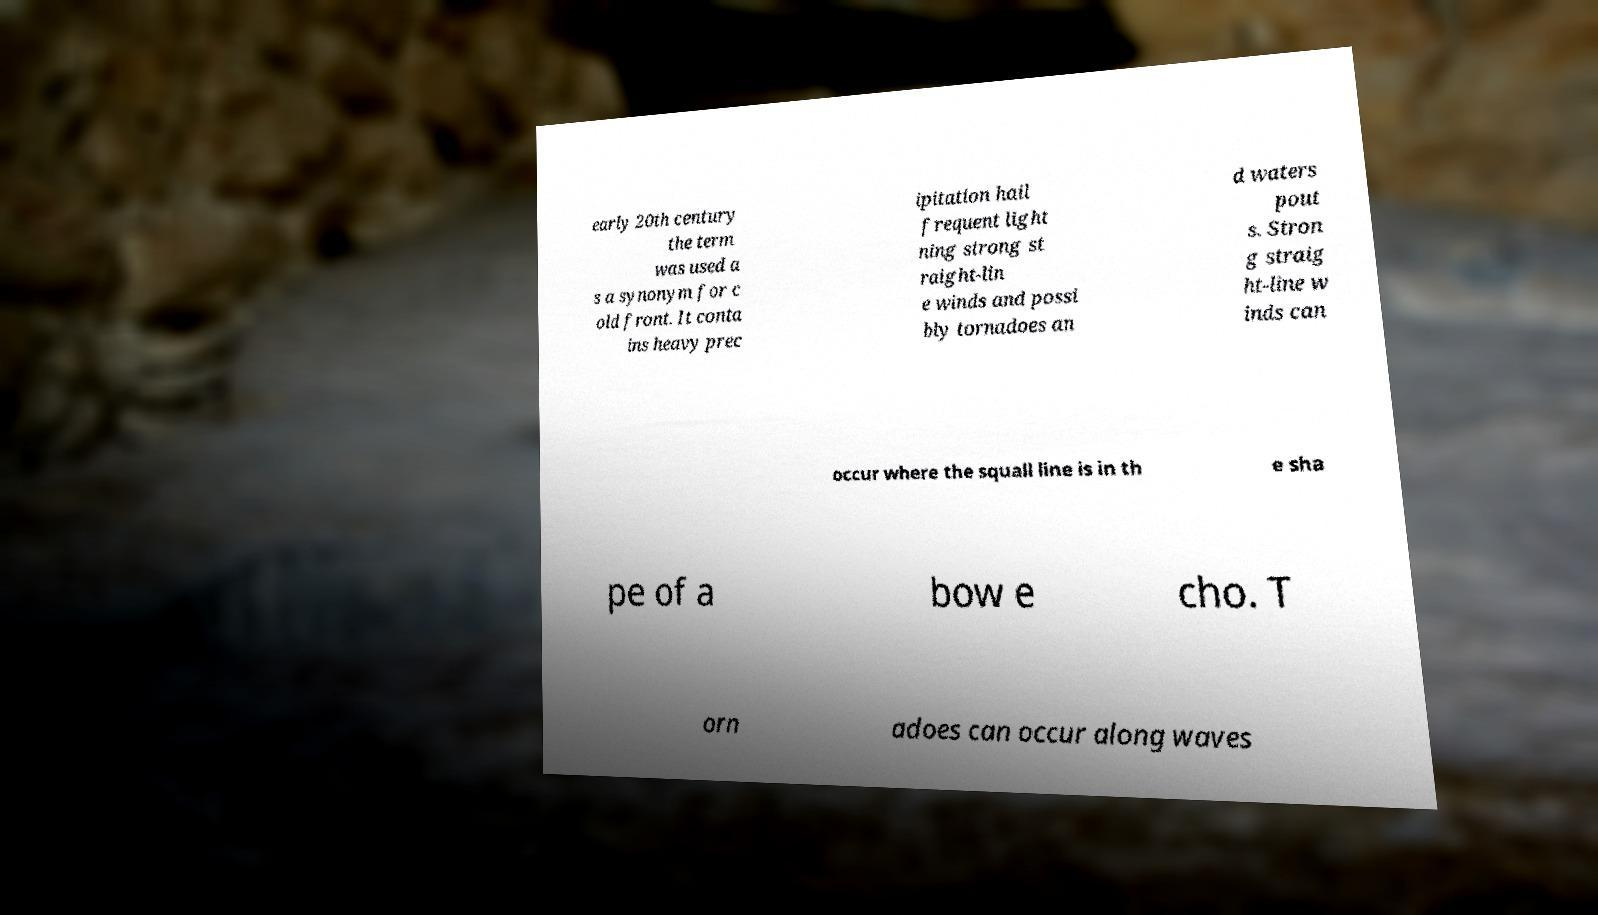Can you accurately transcribe the text from the provided image for me? early 20th century the term was used a s a synonym for c old front. It conta ins heavy prec ipitation hail frequent light ning strong st raight-lin e winds and possi bly tornadoes an d waters pout s. Stron g straig ht-line w inds can occur where the squall line is in th e sha pe of a bow e cho. T orn adoes can occur along waves 